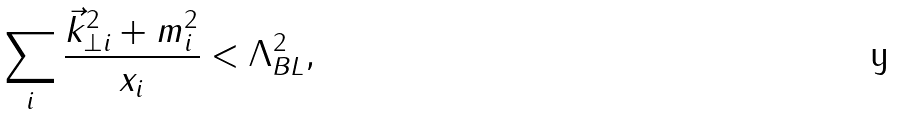<formula> <loc_0><loc_0><loc_500><loc_500>\sum _ { i } \frac { { \vec { k } } _ { \perp i } ^ { 2 } + m _ { i } ^ { 2 } } { x _ { i } } < \Lambda _ { B L } ^ { 2 } ,</formula> 